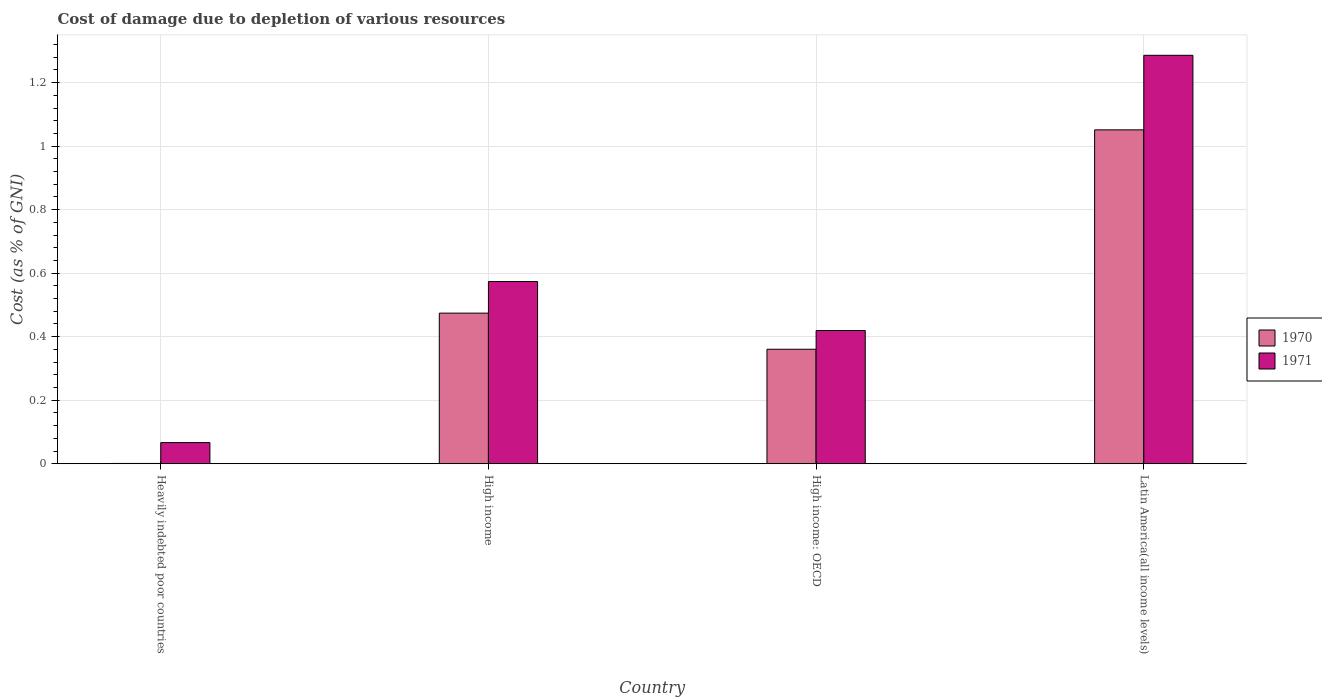How many different coloured bars are there?
Make the answer very short. 2. Are the number of bars per tick equal to the number of legend labels?
Offer a very short reply. Yes. Are the number of bars on each tick of the X-axis equal?
Your answer should be compact. Yes. What is the label of the 2nd group of bars from the left?
Keep it short and to the point. High income. What is the cost of damage caused due to the depletion of various resources in 1971 in High income: OECD?
Your response must be concise. 0.42. Across all countries, what is the maximum cost of damage caused due to the depletion of various resources in 1970?
Make the answer very short. 1.05. Across all countries, what is the minimum cost of damage caused due to the depletion of various resources in 1970?
Ensure brevity in your answer.  0. In which country was the cost of damage caused due to the depletion of various resources in 1970 maximum?
Your response must be concise. Latin America(all income levels). In which country was the cost of damage caused due to the depletion of various resources in 1970 minimum?
Your answer should be very brief. Heavily indebted poor countries. What is the total cost of damage caused due to the depletion of various resources in 1970 in the graph?
Your answer should be compact. 1.89. What is the difference between the cost of damage caused due to the depletion of various resources in 1971 in Heavily indebted poor countries and that in Latin America(all income levels)?
Give a very brief answer. -1.22. What is the difference between the cost of damage caused due to the depletion of various resources in 1971 in High income: OECD and the cost of damage caused due to the depletion of various resources in 1970 in High income?
Make the answer very short. -0.05. What is the average cost of damage caused due to the depletion of various resources in 1970 per country?
Give a very brief answer. 0.47. What is the difference between the cost of damage caused due to the depletion of various resources of/in 1970 and cost of damage caused due to the depletion of various resources of/in 1971 in Latin America(all income levels)?
Your response must be concise. -0.23. In how many countries, is the cost of damage caused due to the depletion of various resources in 1970 greater than 1.2400000000000002 %?
Offer a very short reply. 0. What is the ratio of the cost of damage caused due to the depletion of various resources in 1971 in High income to that in High income: OECD?
Your response must be concise. 1.37. Is the difference between the cost of damage caused due to the depletion of various resources in 1970 in Heavily indebted poor countries and Latin America(all income levels) greater than the difference between the cost of damage caused due to the depletion of various resources in 1971 in Heavily indebted poor countries and Latin America(all income levels)?
Offer a very short reply. Yes. What is the difference between the highest and the second highest cost of damage caused due to the depletion of various resources in 1970?
Offer a very short reply. -0.58. What is the difference between the highest and the lowest cost of damage caused due to the depletion of various resources in 1970?
Offer a terse response. 1.05. In how many countries, is the cost of damage caused due to the depletion of various resources in 1970 greater than the average cost of damage caused due to the depletion of various resources in 1970 taken over all countries?
Offer a terse response. 2. What does the 1st bar from the left in High income: OECD represents?
Keep it short and to the point. 1970. What does the 1st bar from the right in High income represents?
Keep it short and to the point. 1971. How many bars are there?
Make the answer very short. 8. How many countries are there in the graph?
Make the answer very short. 4. What is the difference between two consecutive major ticks on the Y-axis?
Offer a very short reply. 0.2. Are the values on the major ticks of Y-axis written in scientific E-notation?
Keep it short and to the point. No. Does the graph contain grids?
Provide a succinct answer. Yes. Where does the legend appear in the graph?
Offer a terse response. Center right. How many legend labels are there?
Your answer should be very brief. 2. What is the title of the graph?
Ensure brevity in your answer.  Cost of damage due to depletion of various resources. Does "1970" appear as one of the legend labels in the graph?
Your answer should be very brief. Yes. What is the label or title of the X-axis?
Your answer should be very brief. Country. What is the label or title of the Y-axis?
Make the answer very short. Cost (as % of GNI). What is the Cost (as % of GNI) of 1970 in Heavily indebted poor countries?
Offer a terse response. 0. What is the Cost (as % of GNI) in 1971 in Heavily indebted poor countries?
Ensure brevity in your answer.  0.07. What is the Cost (as % of GNI) in 1970 in High income?
Give a very brief answer. 0.47. What is the Cost (as % of GNI) in 1971 in High income?
Ensure brevity in your answer.  0.57. What is the Cost (as % of GNI) of 1970 in High income: OECD?
Provide a short and direct response. 0.36. What is the Cost (as % of GNI) in 1971 in High income: OECD?
Provide a succinct answer. 0.42. What is the Cost (as % of GNI) in 1970 in Latin America(all income levels)?
Offer a terse response. 1.05. What is the Cost (as % of GNI) of 1971 in Latin America(all income levels)?
Provide a short and direct response. 1.29. Across all countries, what is the maximum Cost (as % of GNI) of 1970?
Offer a terse response. 1.05. Across all countries, what is the maximum Cost (as % of GNI) in 1971?
Ensure brevity in your answer.  1.29. Across all countries, what is the minimum Cost (as % of GNI) of 1970?
Offer a very short reply. 0. Across all countries, what is the minimum Cost (as % of GNI) of 1971?
Your answer should be compact. 0.07. What is the total Cost (as % of GNI) in 1970 in the graph?
Offer a terse response. 1.89. What is the total Cost (as % of GNI) of 1971 in the graph?
Ensure brevity in your answer.  2.35. What is the difference between the Cost (as % of GNI) of 1970 in Heavily indebted poor countries and that in High income?
Provide a short and direct response. -0.47. What is the difference between the Cost (as % of GNI) in 1971 in Heavily indebted poor countries and that in High income?
Offer a terse response. -0.51. What is the difference between the Cost (as % of GNI) in 1970 in Heavily indebted poor countries and that in High income: OECD?
Make the answer very short. -0.36. What is the difference between the Cost (as % of GNI) of 1971 in Heavily indebted poor countries and that in High income: OECD?
Make the answer very short. -0.35. What is the difference between the Cost (as % of GNI) of 1970 in Heavily indebted poor countries and that in Latin America(all income levels)?
Make the answer very short. -1.05. What is the difference between the Cost (as % of GNI) of 1971 in Heavily indebted poor countries and that in Latin America(all income levels)?
Provide a succinct answer. -1.22. What is the difference between the Cost (as % of GNI) in 1970 in High income and that in High income: OECD?
Provide a succinct answer. 0.11. What is the difference between the Cost (as % of GNI) of 1971 in High income and that in High income: OECD?
Your answer should be very brief. 0.15. What is the difference between the Cost (as % of GNI) in 1970 in High income and that in Latin America(all income levels)?
Keep it short and to the point. -0.58. What is the difference between the Cost (as % of GNI) in 1971 in High income and that in Latin America(all income levels)?
Make the answer very short. -0.71. What is the difference between the Cost (as % of GNI) in 1970 in High income: OECD and that in Latin America(all income levels)?
Your answer should be compact. -0.69. What is the difference between the Cost (as % of GNI) of 1971 in High income: OECD and that in Latin America(all income levels)?
Provide a succinct answer. -0.87. What is the difference between the Cost (as % of GNI) of 1970 in Heavily indebted poor countries and the Cost (as % of GNI) of 1971 in High income?
Your response must be concise. -0.57. What is the difference between the Cost (as % of GNI) of 1970 in Heavily indebted poor countries and the Cost (as % of GNI) of 1971 in High income: OECD?
Offer a terse response. -0.42. What is the difference between the Cost (as % of GNI) of 1970 in Heavily indebted poor countries and the Cost (as % of GNI) of 1971 in Latin America(all income levels)?
Give a very brief answer. -1.29. What is the difference between the Cost (as % of GNI) of 1970 in High income and the Cost (as % of GNI) of 1971 in High income: OECD?
Your answer should be very brief. 0.05. What is the difference between the Cost (as % of GNI) of 1970 in High income and the Cost (as % of GNI) of 1971 in Latin America(all income levels)?
Keep it short and to the point. -0.81. What is the difference between the Cost (as % of GNI) of 1970 in High income: OECD and the Cost (as % of GNI) of 1971 in Latin America(all income levels)?
Make the answer very short. -0.93. What is the average Cost (as % of GNI) of 1970 per country?
Your answer should be very brief. 0.47. What is the average Cost (as % of GNI) in 1971 per country?
Your answer should be very brief. 0.59. What is the difference between the Cost (as % of GNI) of 1970 and Cost (as % of GNI) of 1971 in Heavily indebted poor countries?
Provide a succinct answer. -0.07. What is the difference between the Cost (as % of GNI) in 1970 and Cost (as % of GNI) in 1971 in High income?
Keep it short and to the point. -0.1. What is the difference between the Cost (as % of GNI) in 1970 and Cost (as % of GNI) in 1971 in High income: OECD?
Keep it short and to the point. -0.06. What is the difference between the Cost (as % of GNI) of 1970 and Cost (as % of GNI) of 1971 in Latin America(all income levels)?
Offer a very short reply. -0.23. What is the ratio of the Cost (as % of GNI) of 1970 in Heavily indebted poor countries to that in High income?
Give a very brief answer. 0. What is the ratio of the Cost (as % of GNI) of 1971 in Heavily indebted poor countries to that in High income?
Your answer should be compact. 0.12. What is the ratio of the Cost (as % of GNI) of 1970 in Heavily indebted poor countries to that in High income: OECD?
Offer a terse response. 0. What is the ratio of the Cost (as % of GNI) of 1971 in Heavily indebted poor countries to that in High income: OECD?
Your answer should be compact. 0.16. What is the ratio of the Cost (as % of GNI) of 1970 in Heavily indebted poor countries to that in Latin America(all income levels)?
Ensure brevity in your answer.  0. What is the ratio of the Cost (as % of GNI) of 1971 in Heavily indebted poor countries to that in Latin America(all income levels)?
Your answer should be compact. 0.05. What is the ratio of the Cost (as % of GNI) of 1970 in High income to that in High income: OECD?
Make the answer very short. 1.32. What is the ratio of the Cost (as % of GNI) of 1971 in High income to that in High income: OECD?
Your answer should be compact. 1.37. What is the ratio of the Cost (as % of GNI) in 1970 in High income to that in Latin America(all income levels)?
Provide a succinct answer. 0.45. What is the ratio of the Cost (as % of GNI) in 1971 in High income to that in Latin America(all income levels)?
Your response must be concise. 0.45. What is the ratio of the Cost (as % of GNI) in 1970 in High income: OECD to that in Latin America(all income levels)?
Provide a short and direct response. 0.34. What is the ratio of the Cost (as % of GNI) in 1971 in High income: OECD to that in Latin America(all income levels)?
Offer a very short reply. 0.33. What is the difference between the highest and the second highest Cost (as % of GNI) in 1970?
Your answer should be compact. 0.58. What is the difference between the highest and the second highest Cost (as % of GNI) in 1971?
Give a very brief answer. 0.71. What is the difference between the highest and the lowest Cost (as % of GNI) in 1970?
Your answer should be very brief. 1.05. What is the difference between the highest and the lowest Cost (as % of GNI) in 1971?
Provide a succinct answer. 1.22. 